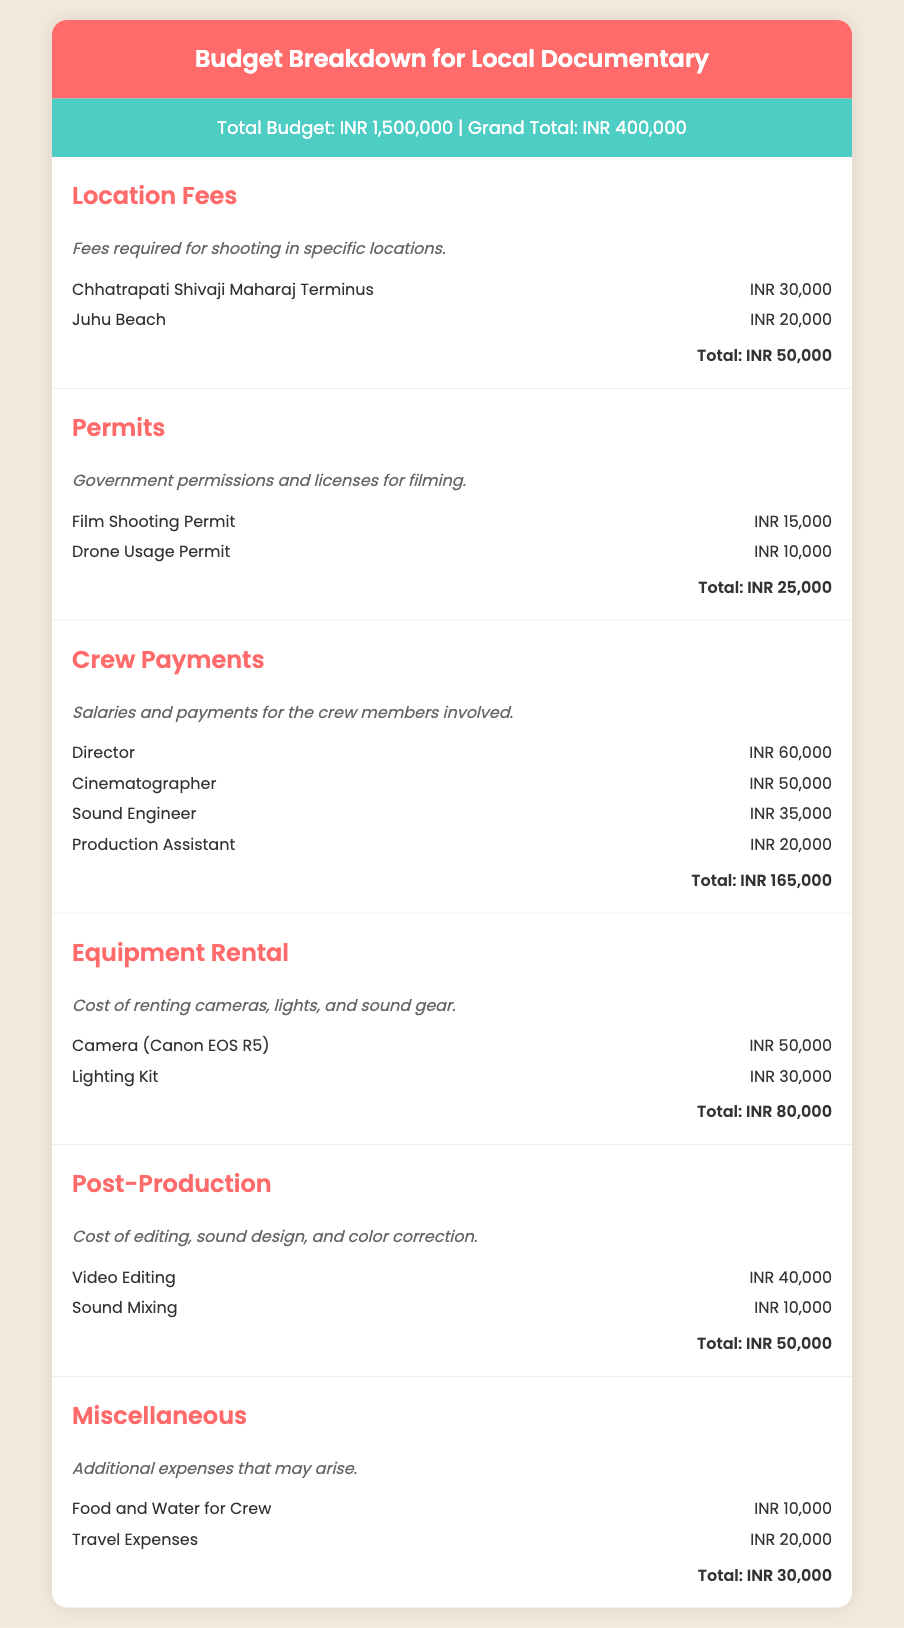What is the total budget for the documentary? The total budget is mentioned at the beginning of the document, which includes all expenses and revenues.
Answer: INR 1,500,000 What is the location fee for Juhu Beach? The specific expense for shooting at Juhu Beach is listed under Location Fees in the document.
Answer: INR 20,000 How much does the cinematographer get paid? The payment for the cinematographer is provided in the Crew Payments category.
Answer: INR 50,000 What is the total cost for permits? The total sum of costs associated with permits can be found in the Permits section of the document.
Answer: INR 25,000 Which piece of equipment has the highest rental cost? The equipment with the highest rental cost is mentioned in the Equipment Rental category.
Answer: Camera (Canon EOS R5) What is the budget allocation for food and water for the crew? The specific expense for food and water is included in the Miscellaneous category.
Answer: INR 10,000 How much is allocated for video editing in post-production? The cost allocated for video editing is specified in the Post-Production section.
Answer: INR 40,000 What is the total crew payment? The total amount paid to crew members is summarized in the Crew Payments section.
Answer: INR 165,000 What additional expenses are included under miscellaneous costs? The miscellaneous costs detail expenses that arise outside of the major categories, found in the Miscellaneous section.
Answer: Food and Water for Crew, Travel Expenses 